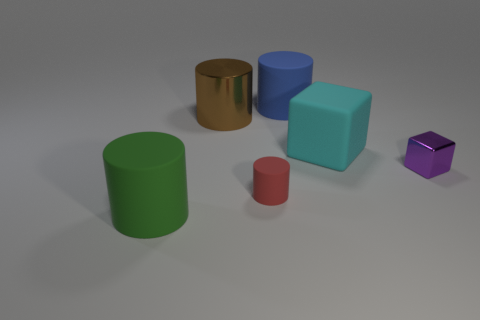Subtract all large green matte cylinders. How many cylinders are left? 3 Subtract all blue cylinders. How many cylinders are left? 3 Subtract 1 cylinders. How many cylinders are left? 3 Add 1 red matte cylinders. How many objects exist? 7 Subtract all cubes. How many objects are left? 4 Subtract all big blue matte spheres. Subtract all tiny red objects. How many objects are left? 5 Add 4 green rubber things. How many green rubber things are left? 5 Add 5 red rubber things. How many red rubber things exist? 6 Subtract 0 red spheres. How many objects are left? 6 Subtract all brown cylinders. Subtract all red spheres. How many cylinders are left? 3 